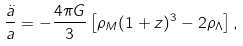<formula> <loc_0><loc_0><loc_500><loc_500>\frac { \ddot { a } } { a } = - \frac { 4 \pi G } { 3 } \left [ \rho _ { M } ( 1 + z ) ^ { 3 } - 2 \rho _ { \Lambda } \right ] ,</formula> 